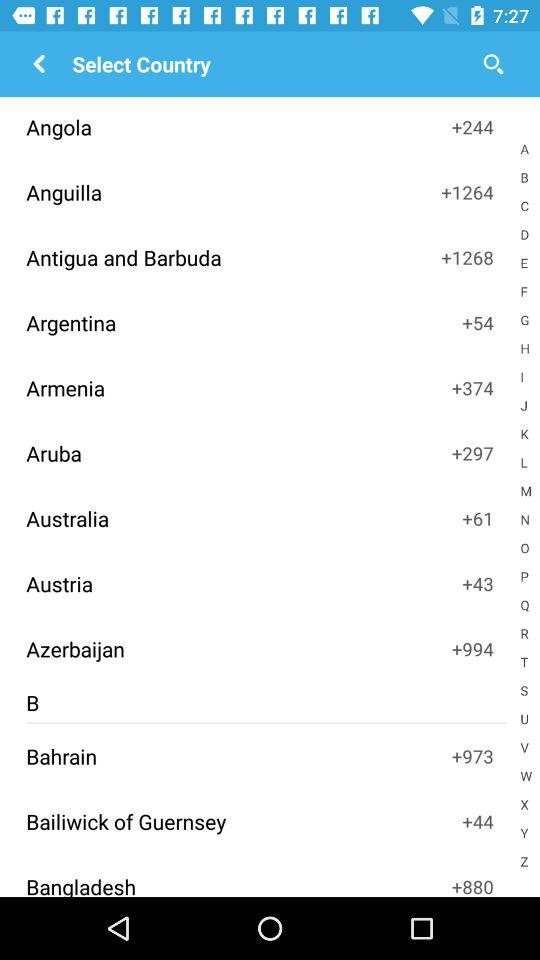How many points does Aruba have? Aruba has +297 points. 